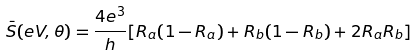Convert formula to latex. <formula><loc_0><loc_0><loc_500><loc_500>\bar { S } ( e V , \theta ) = \frac { 4 e ^ { 3 } } { h } [ R _ { a } ( 1 - R _ { a } ) + R _ { b } ( 1 - R _ { b } ) + 2 R _ { a } R _ { b } ]</formula> 